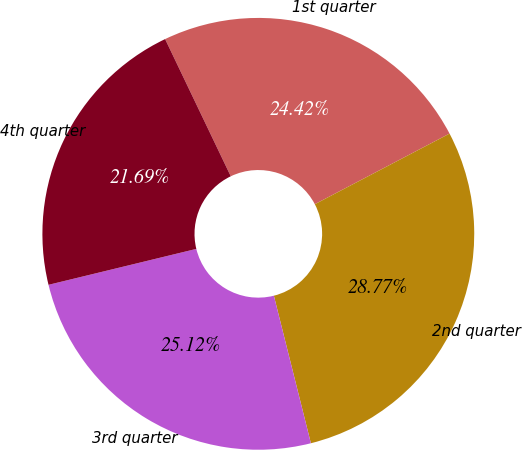Convert chart to OTSL. <chart><loc_0><loc_0><loc_500><loc_500><pie_chart><fcel>1st quarter<fcel>2nd quarter<fcel>3rd quarter<fcel>4th quarter<nl><fcel>24.42%<fcel>28.77%<fcel>25.12%<fcel>21.69%<nl></chart> 